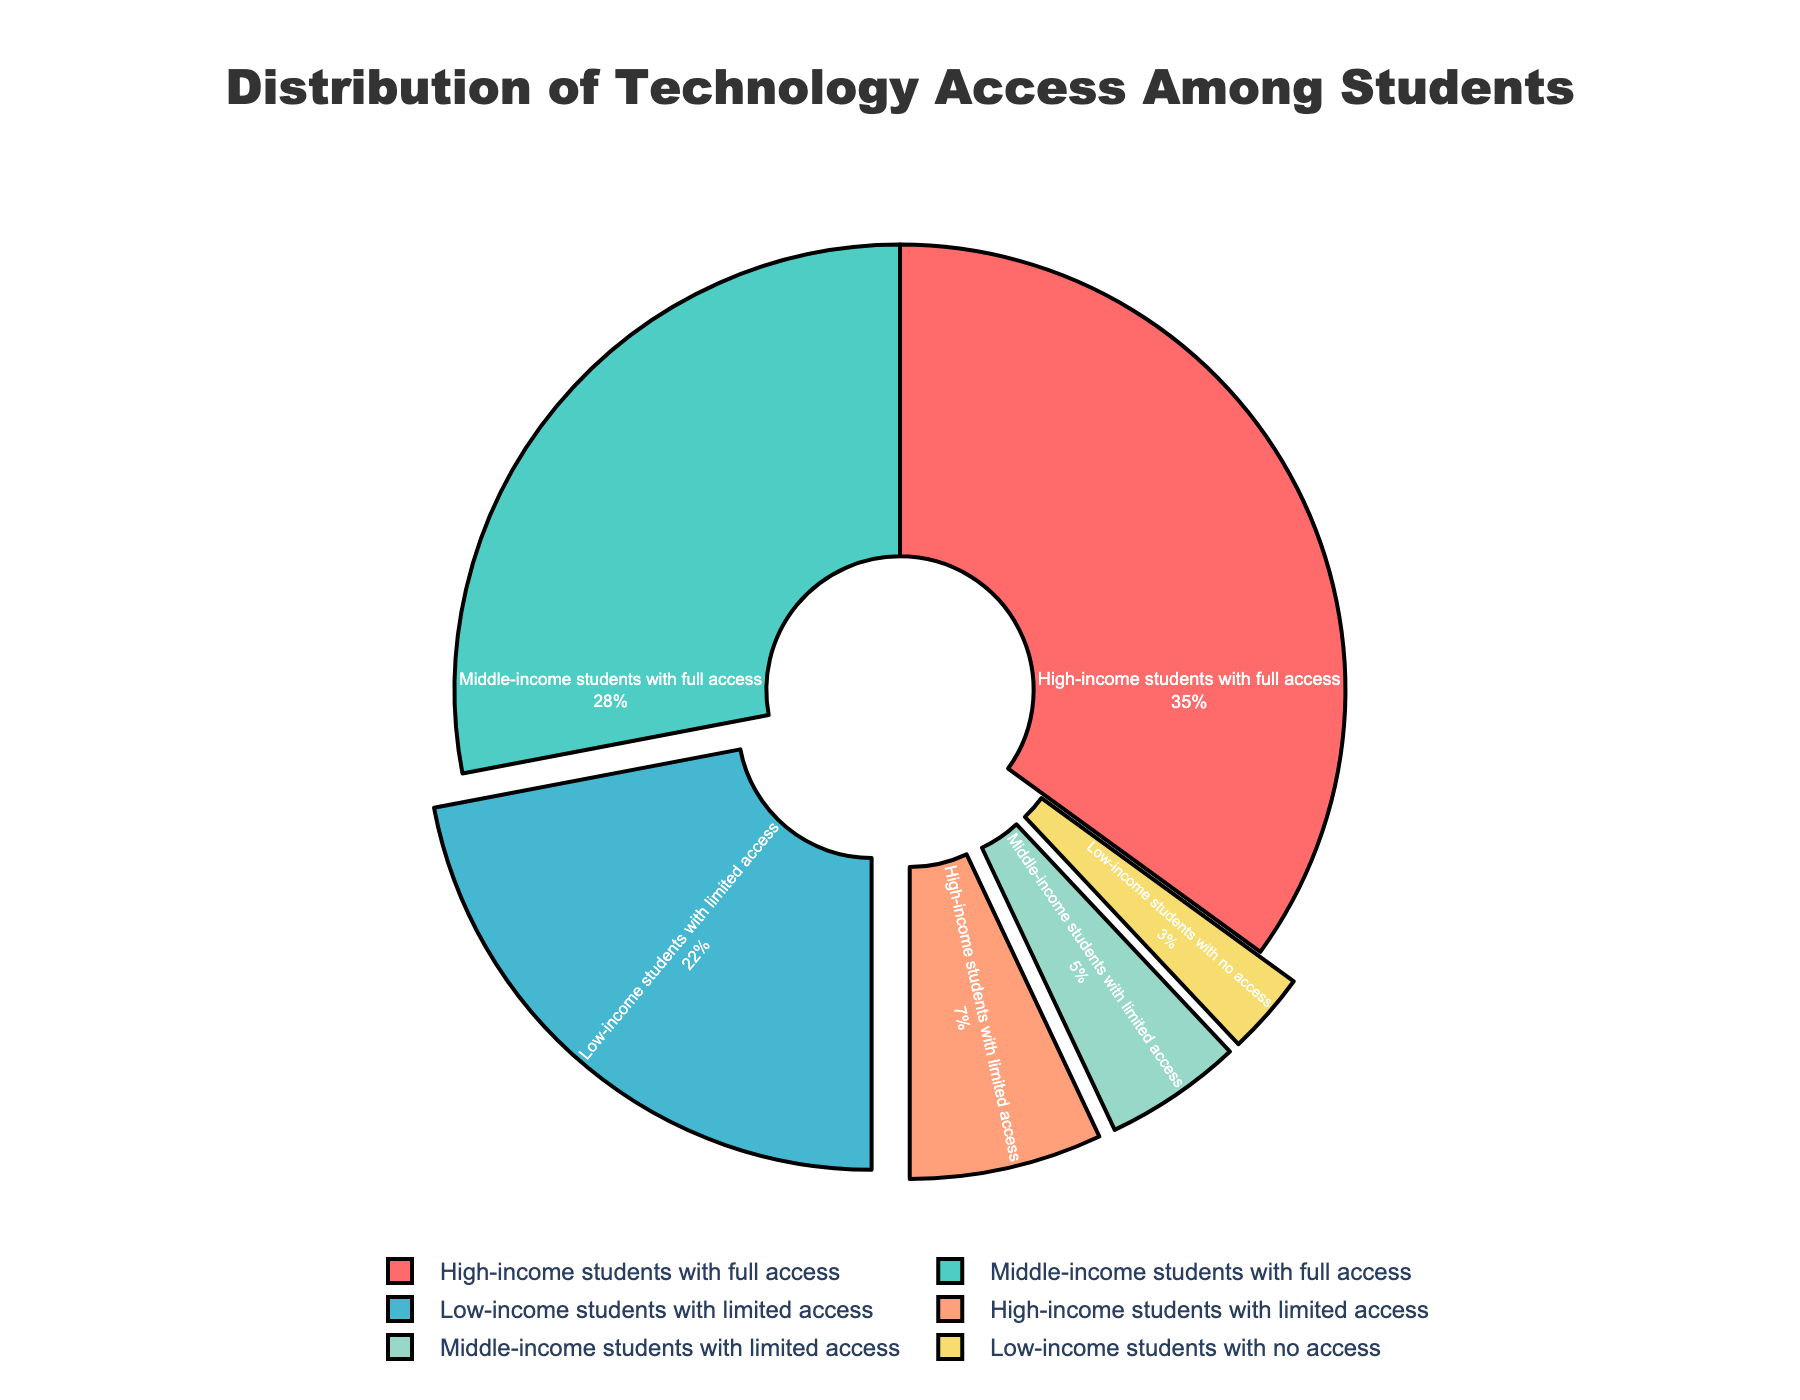Which group has the highest percentage of technology access? The slice labelled "High-income students with full access" is the largest in the pie chart, occupying 35% of the distribution.
Answer: High-income students with full access How much higher is the percentage of high-income students with full access compared to low-income students with no access? The percentage of high-income students with full access is 35%, and the percentage of low-income students with no access is 3%. The difference between these two percentages is 35% - 3% = 32%.
Answer: 32% What is the total percentage of students with limited or no access to technology? The relevant slices are "Low-income students with limited access" (22%), "High-income students with limited access" (7%), "Middle-income students with limited access" (5%), and "Low-income students with no access" (3%). Summing these up: 22% + 7% + 5% + 3% = 37%.
Answer: 37% Which socioeconomic group has the smallest proportion without any access to technology? The slice representing "Low-income students with no access" is the smallest, at 3%. No other group has a slice labelled "no access".
Answer: Low-income students Is the percentage of middle-income students with full access greater than the percentage of high-income students with limited access? The percentage of middle-income students with full access is 28%, and the percentage of high-income students with limited access is 7%. 28% is greater than 7%.
Answer: Yes What is the combined percentage of high-income and middle-income students with full access? The slices "High-income students with full access" and "Middle-income students with full access" are 35% and 28%, respectively. The combined percentage is 35% + 28% = 63%.
Answer: 63% What is the difference in percentages between middle-income students with limited access and low-income students with limited access? The percentage of middle-income students with limited access is 5%, and for low-income students with limited access, it is 22%. The difference is 22% - 5% = 17%.
Answer: 17% What percentage of students have full access to technology? The relevant slices are "High-income students with full access" (35%) and "Middle-income students with full access" (28%). The total percentage is 35% + 28% = 63%.
Answer: 63% Which has a higher percentage: low-income students with limited access or middle-income students with full access? The percentage of low-income students with limited access is 22%, and the percentage of middle-income students with full access is 28%. 28% is higher than 22%.
Answer: Middle-income students with full access 